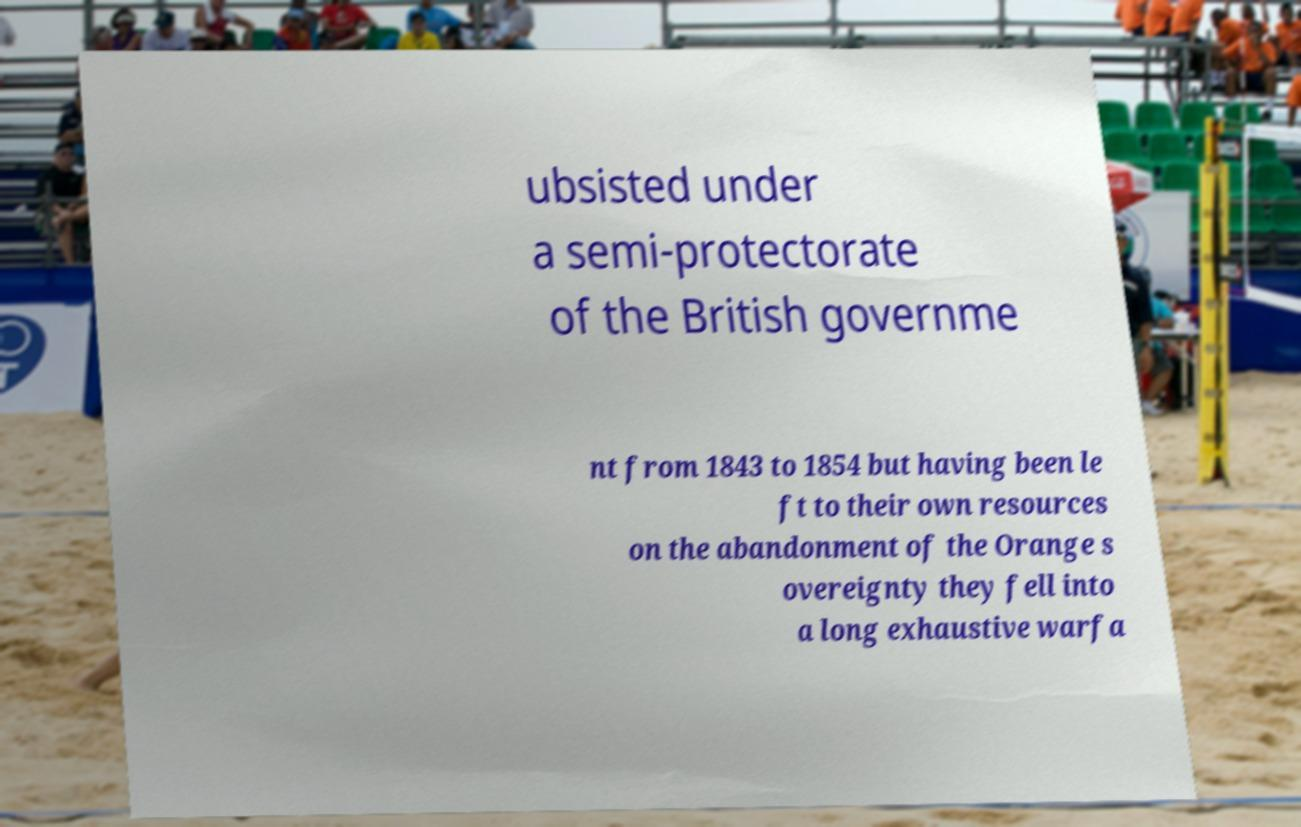There's text embedded in this image that I need extracted. Can you transcribe it verbatim? ubsisted under a semi-protectorate of the British governme nt from 1843 to 1854 but having been le ft to their own resources on the abandonment of the Orange s overeignty they fell into a long exhaustive warfa 